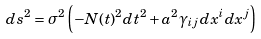<formula> <loc_0><loc_0><loc_500><loc_500>d s ^ { 2 } = \sigma ^ { 2 } \left ( - N ( t ) ^ { 2 } d t ^ { 2 } + a ^ { 2 } \gamma _ { i j } d x ^ { i } d x ^ { j } \right )</formula> 